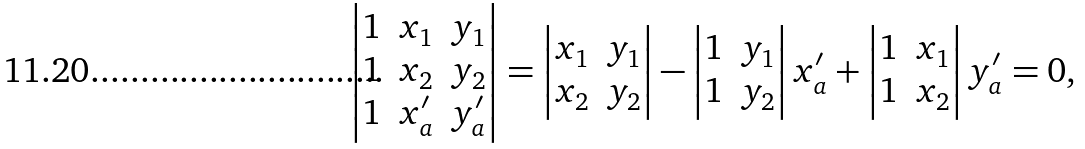Convert formula to latex. <formula><loc_0><loc_0><loc_500><loc_500>\left | \begin{matrix} 1 & x _ { 1 } & y _ { 1 } \\ 1 & x _ { 2 } & y _ { 2 } \\ 1 & x _ { a } ^ { \prime } & y _ { a } ^ { \prime } \\ \end{matrix} \right | = \left | \begin{matrix} x _ { 1 } & y _ { 1 } \\ x _ { 2 } & y _ { 2 } \\ \end{matrix} \right | - \left | \begin{matrix} 1 & y _ { 1 } \\ 1 & y _ { 2 } \\ \end{matrix} \right | x _ { a } ^ { \prime } + \left | \begin{matrix} 1 & x _ { 1 } \\ 1 & x _ { 2 } \\ \end{matrix} \right | y _ { a } ^ { \prime } = 0 ,</formula> 